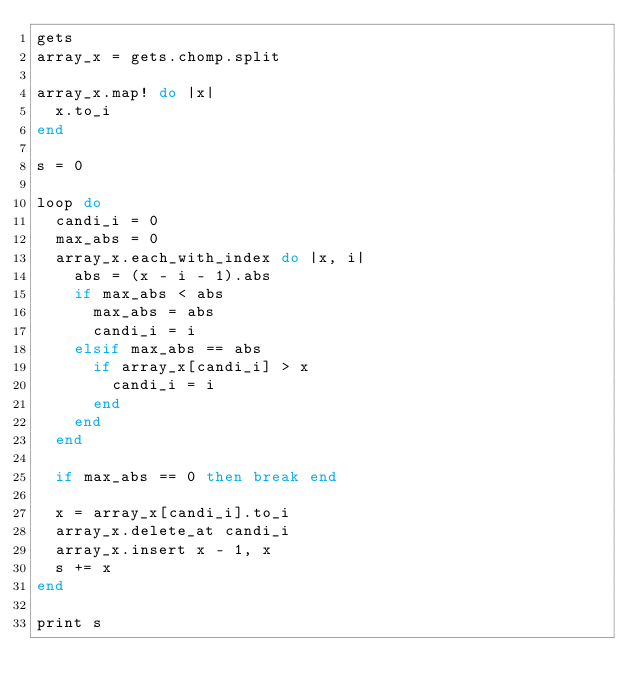Convert code to text. <code><loc_0><loc_0><loc_500><loc_500><_Ruby_>gets
array_x = gets.chomp.split

array_x.map! do |x|
  x.to_i
end

s = 0

loop do
  candi_i = 0
  max_abs = 0
  array_x.each_with_index do |x, i|
    abs = (x - i - 1).abs
    if max_abs < abs
      max_abs = abs
      candi_i = i
    elsif max_abs == abs
      if array_x[candi_i] > x
        candi_i = i
      end
    end
  end
  
  if max_abs == 0 then break end

  x = array_x[candi_i].to_i
  array_x.delete_at candi_i
  array_x.insert x - 1, x
  s += x
end

print s</code> 